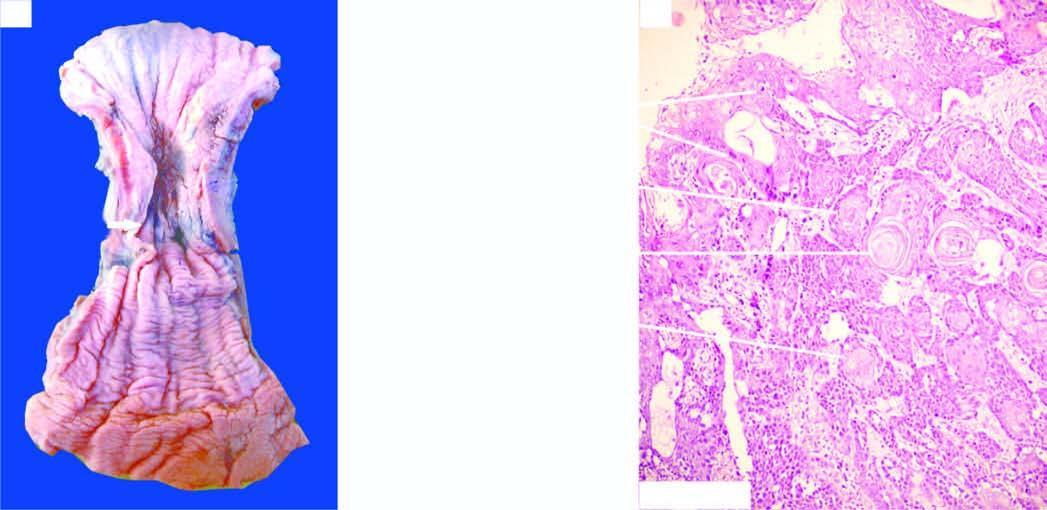s there a concentric circumferential thickening in the middle causing narrowing of the lumen?
Answer the question using a single word or phrase. Yes 